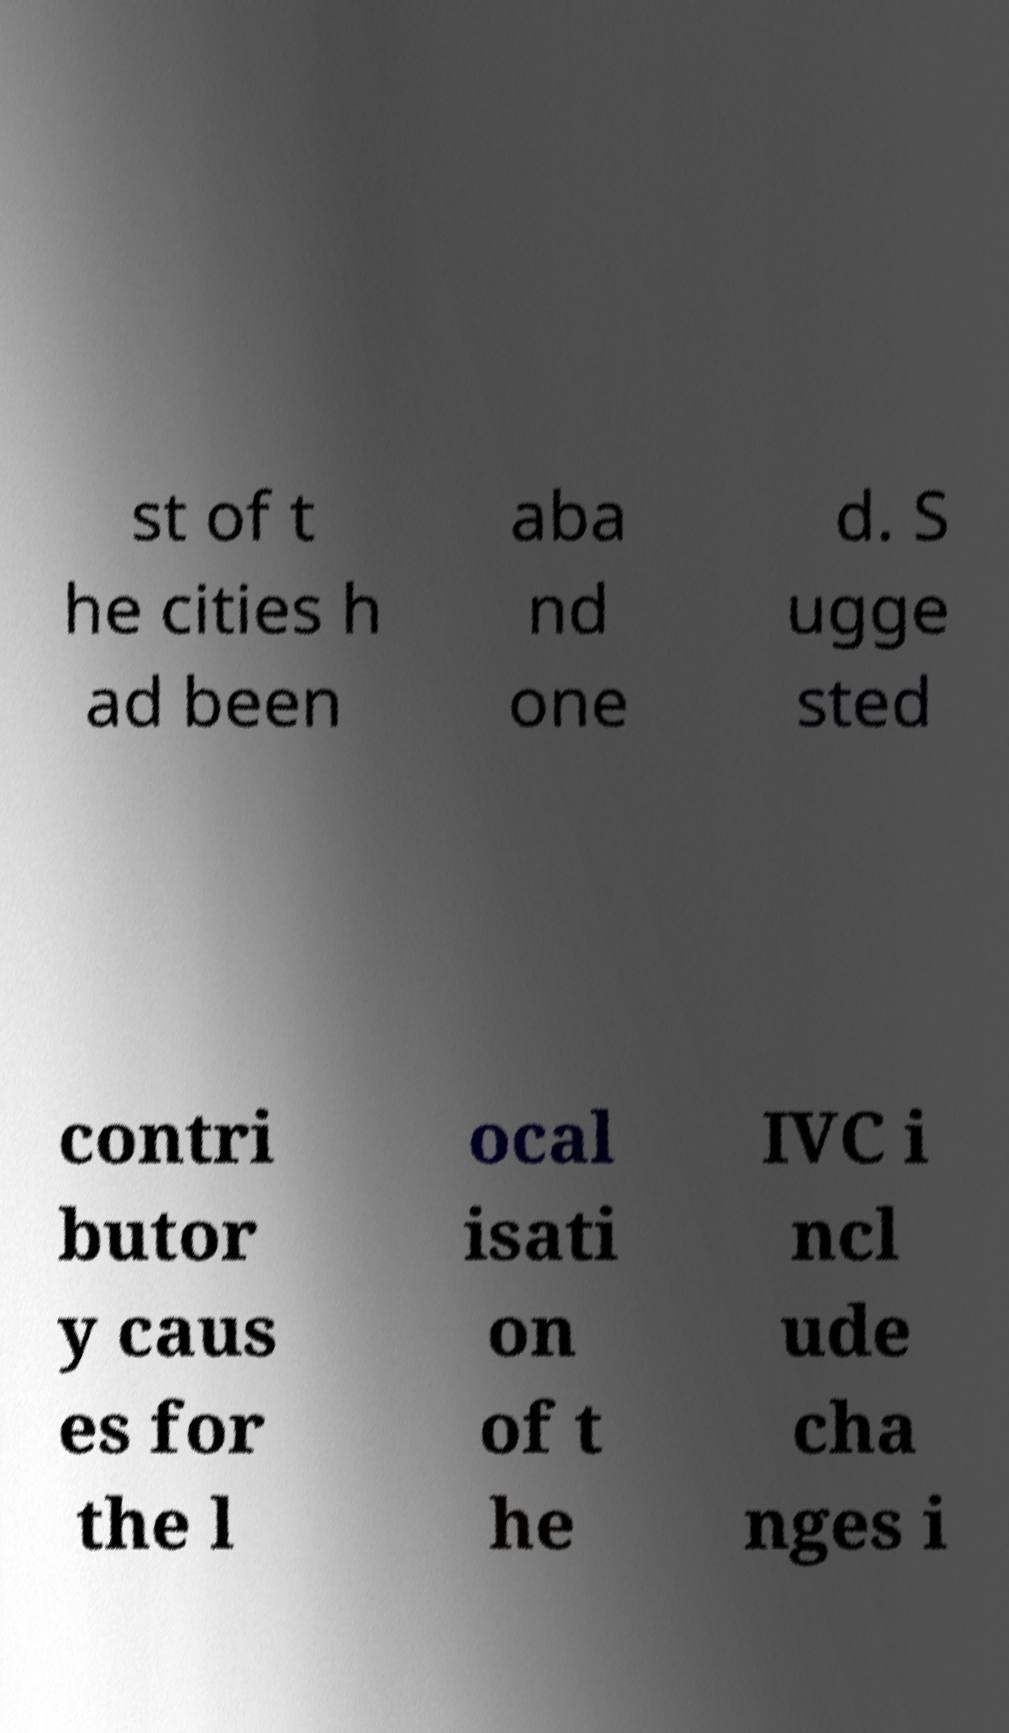What messages or text are displayed in this image? I need them in a readable, typed format. st of t he cities h ad been aba nd one d. S ugge sted contri butor y caus es for the l ocal isati on of t he IVC i ncl ude cha nges i 